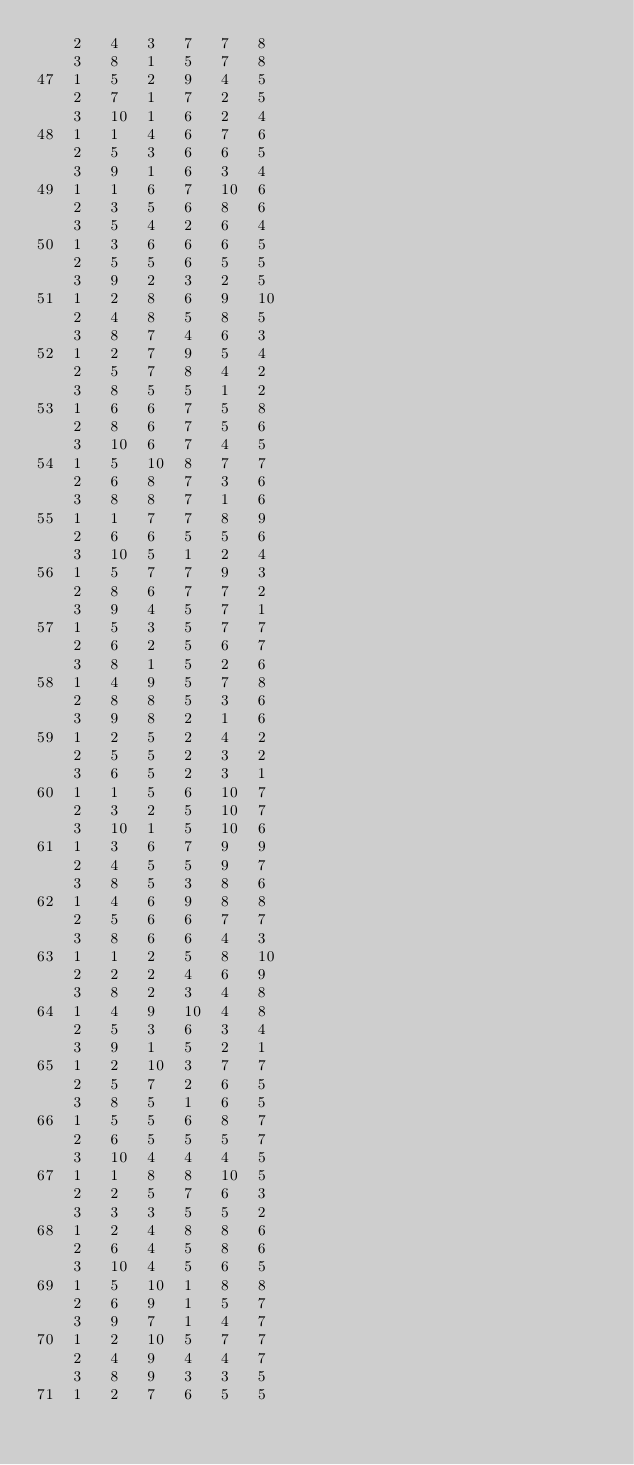<code> <loc_0><loc_0><loc_500><loc_500><_ObjectiveC_>	2	4	3	7	7	8	
	3	8	1	5	7	8	
47	1	5	2	9	4	5	
	2	7	1	7	2	5	
	3	10	1	6	2	4	
48	1	1	4	6	7	6	
	2	5	3	6	6	5	
	3	9	1	6	3	4	
49	1	1	6	7	10	6	
	2	3	5	6	8	6	
	3	5	4	2	6	4	
50	1	3	6	6	6	5	
	2	5	5	6	5	5	
	3	9	2	3	2	5	
51	1	2	8	6	9	10	
	2	4	8	5	8	5	
	3	8	7	4	6	3	
52	1	2	7	9	5	4	
	2	5	7	8	4	2	
	3	8	5	5	1	2	
53	1	6	6	7	5	8	
	2	8	6	7	5	6	
	3	10	6	7	4	5	
54	1	5	10	8	7	7	
	2	6	8	7	3	6	
	3	8	8	7	1	6	
55	1	1	7	7	8	9	
	2	6	6	5	5	6	
	3	10	5	1	2	4	
56	1	5	7	7	9	3	
	2	8	6	7	7	2	
	3	9	4	5	7	1	
57	1	5	3	5	7	7	
	2	6	2	5	6	7	
	3	8	1	5	2	6	
58	1	4	9	5	7	8	
	2	8	8	5	3	6	
	3	9	8	2	1	6	
59	1	2	5	2	4	2	
	2	5	5	2	3	2	
	3	6	5	2	3	1	
60	1	1	5	6	10	7	
	2	3	2	5	10	7	
	3	10	1	5	10	6	
61	1	3	6	7	9	9	
	2	4	5	5	9	7	
	3	8	5	3	8	6	
62	1	4	6	9	8	8	
	2	5	6	6	7	7	
	3	8	6	6	4	3	
63	1	1	2	5	8	10	
	2	2	2	4	6	9	
	3	8	2	3	4	8	
64	1	4	9	10	4	8	
	2	5	3	6	3	4	
	3	9	1	5	2	1	
65	1	2	10	3	7	7	
	2	5	7	2	6	5	
	3	8	5	1	6	5	
66	1	5	5	6	8	7	
	2	6	5	5	5	7	
	3	10	4	4	4	5	
67	1	1	8	8	10	5	
	2	2	5	7	6	3	
	3	3	3	5	5	2	
68	1	2	4	8	8	6	
	2	6	4	5	8	6	
	3	10	4	5	6	5	
69	1	5	10	1	8	8	
	2	6	9	1	5	7	
	3	9	7	1	4	7	
70	1	2	10	5	7	7	
	2	4	9	4	4	7	
	3	8	9	3	3	5	
71	1	2	7	6	5	5	</code> 